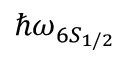Convert formula to latex. <formula><loc_0><loc_0><loc_500><loc_500>\hbar { \omega } _ { 6 S _ { 1 / 2 } }</formula> 